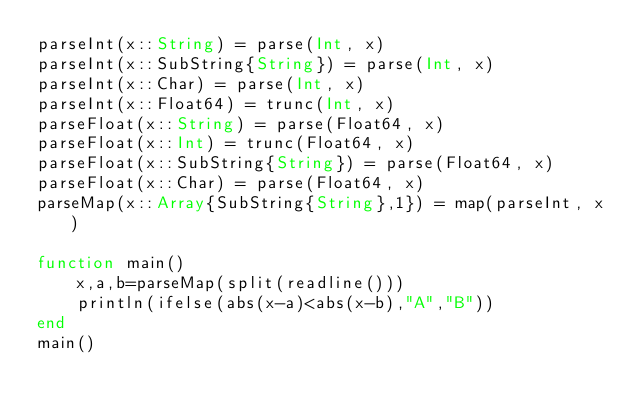<code> <loc_0><loc_0><loc_500><loc_500><_Julia_>parseInt(x::String) = parse(Int, x)
parseInt(x::SubString{String}) = parse(Int, x)
parseInt(x::Char) = parse(Int, x)
parseInt(x::Float64) = trunc(Int, x)
parseFloat(x::String) = parse(Float64, x)
parseFloat(x::Int) = trunc(Float64, x)
parseFloat(x::SubString{String}) = parse(Float64, x)
parseFloat(x::Char) = parse(Float64, x)
parseMap(x::Array{SubString{String},1}) = map(parseInt, x)

function main()
    x,a,b=parseMap(split(readline()))
    println(ifelse(abs(x-a)<abs(x-b),"A","B"))
end
main()</code> 